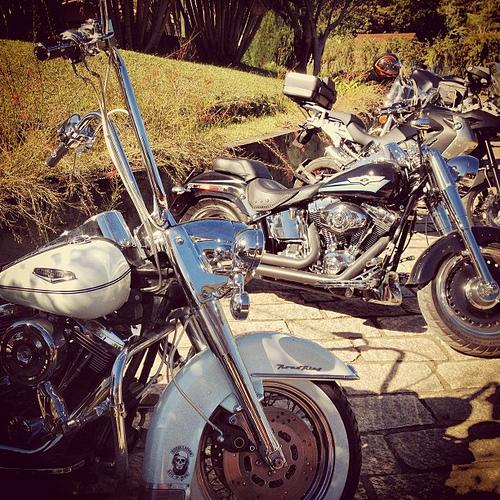Describe what type of ground the motorcycles are parked on and its characteristics. The motorcycles are parked on a gray tiled ground, possibly made of bricks or pavement, which covers a large area in the image. Identify the main focus of the image and describe its surroundings. A row of silver motorcycles is parked on a gray tiled ground surrounded by green grass, with a building and trees in the background. Mention the features and details of the motorcycles in the image. The motorcycles have chrome handlebars, headlights, white wall tires, turn signals, and some have carriers, helmets hanging, and a picture of a skull. For the product advertisement task, briefly state the unique features of the motorcycles in the image. Presenting our impressive lineup of silver motorcycles, featuring white wall tires, chrome handlebars, sleek headlights, skull images, and convenient storage carriers. What is the most noticeable part of the background in the image? A hillside full of green grass and trees growing in the background are the most noticeable parts. For the multi-choice VQA task, pick one motorcycle and describe it in detail. The white motorcycle has a gas tank, front fender, front tire, headlight, handlebars, and a turn signal. Which object can be found at the farthest right of the image? A helmet hanging on a motorcycle can be found at the farthest right of the image. For the visual entailment task, describe what the image entails about the setting of the scene. The image entails that the scene is happening outside during the day, with multiple motorcycles parked on gray tiled ground near a grassy hillside. 